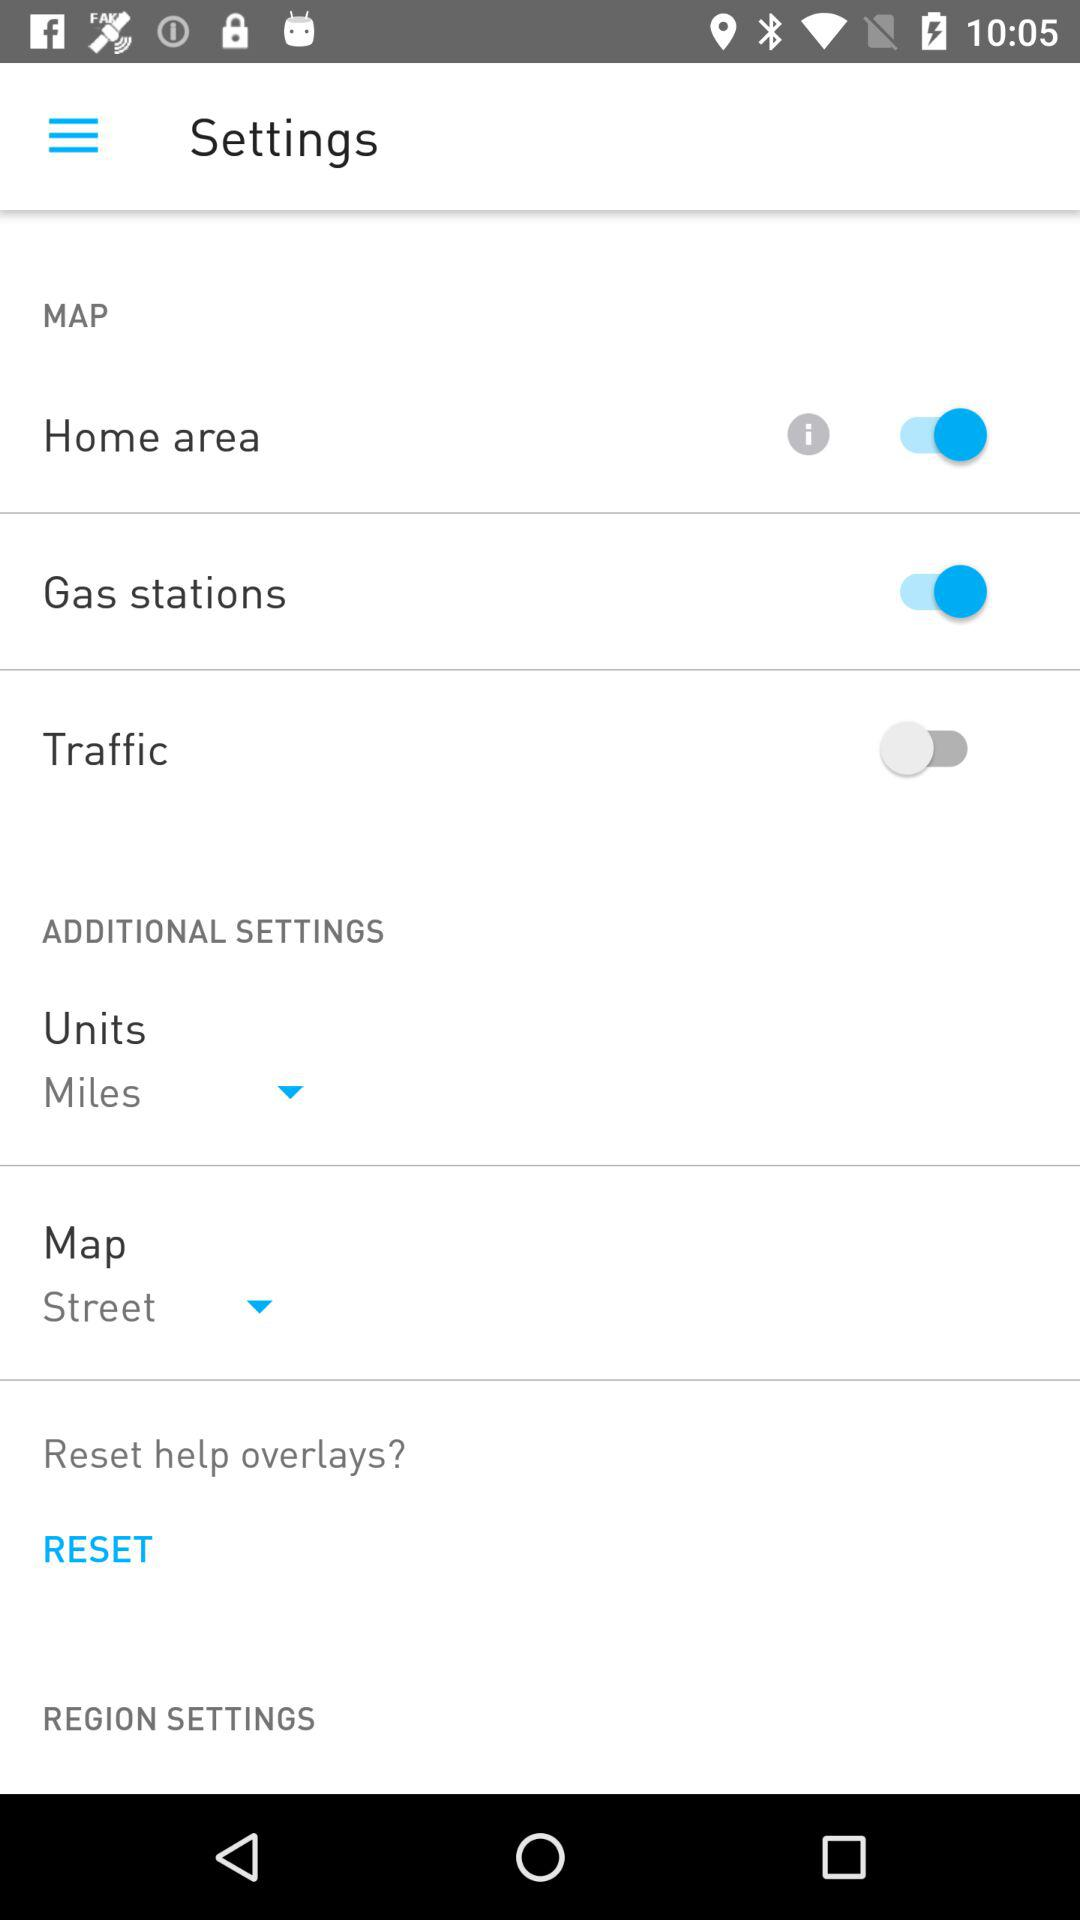How many toggles are in the settings menu?
Answer the question using a single word or phrase. 3 